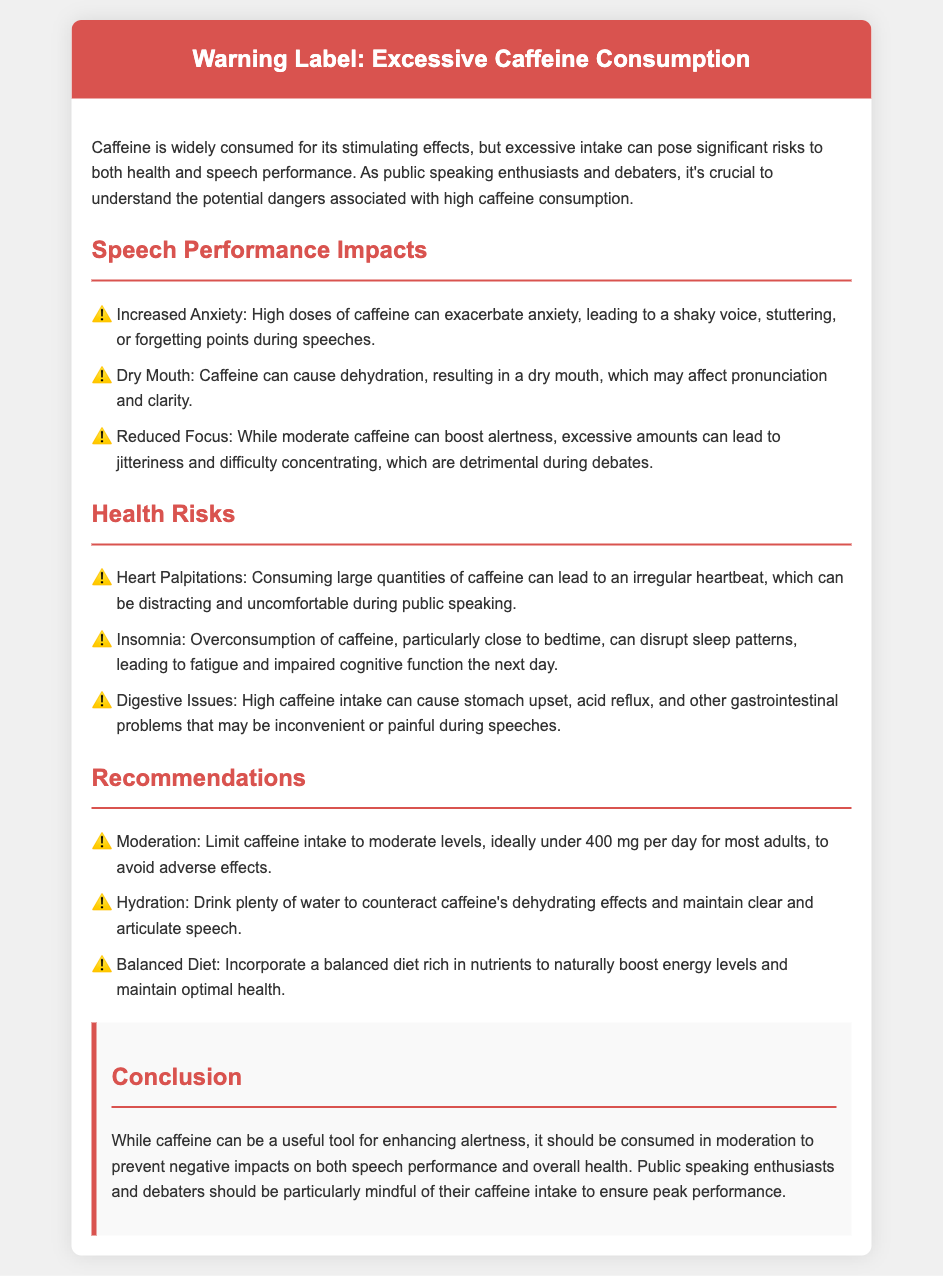What are some impacts of excessive caffeine on speech performance? The document lists three impacts: Increased Anxiety, Dry Mouth, and Reduced Focus.
Answer: Increased Anxiety, Dry Mouth, Reduced Focus What is the recommended maximum caffeine intake for most adults? The document states that the ideal limit for caffeine intake is under 400 mg per day for most adults.
Answer: 400 mg What health risk is associated with high caffeine intake that affects the heart? The document mentions heart palpitations as a health risk associated with high caffeine intake.
Answer: Heart Palpitations What should one drink to counteract caffeine's dehydrating effects? The document advises drinking plenty of water to maintain clear and articulate speech.
Answer: Water How does excessive caffeine affect focus during debates? The document explains that excessive caffeine can lead to jitteriness and difficulty concentrating, which are detrimental during debates.
Answer: Jitteriness and difficulty concentrating What digestive issue could arise from excessive caffeine consumption? The document lists stomach upset as a potential digestive issue from excessive caffeine consumption.
Answer: Stomach upset What is the importance of a balanced diet according to the document? The document emphasizes that a balanced diet rich in nutrients helps to naturally boost energy levels and maintain optimal health.
Answer: Boost energy levels What conclusion is drawn regarding caffeine consumption for public speaking enthusiasts? The conclusion states that caffeine should be consumed in moderation to prevent negative impacts on speech performance and overall health.
Answer: Consumed in moderation 